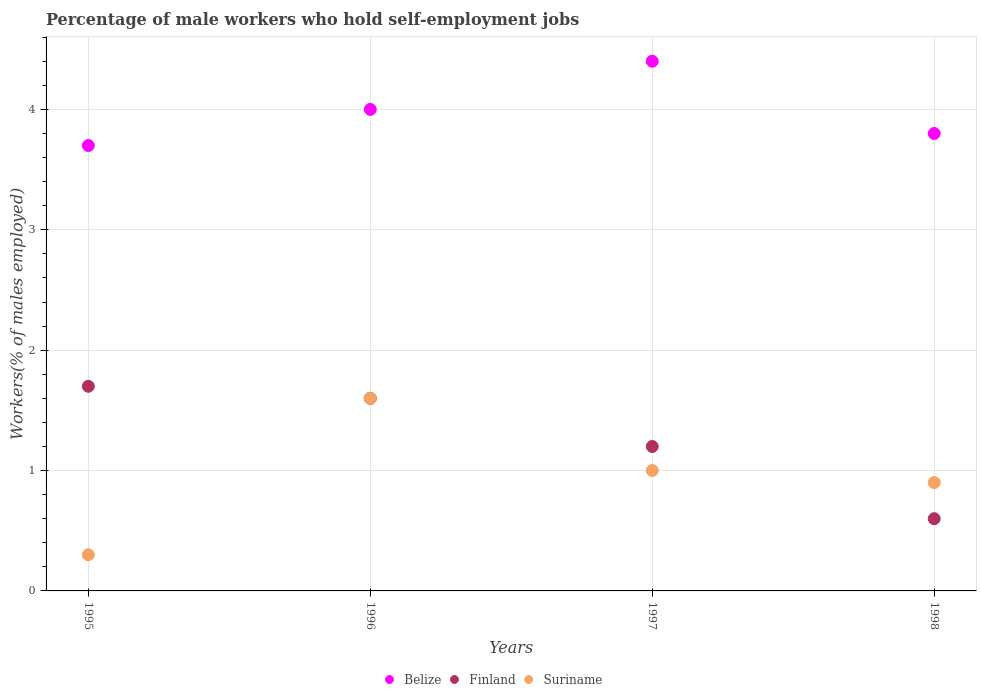How many different coloured dotlines are there?
Keep it short and to the point. 3. Is the number of dotlines equal to the number of legend labels?
Keep it short and to the point. Yes. Across all years, what is the maximum percentage of self-employed male workers in Belize?
Offer a terse response. 4.4. Across all years, what is the minimum percentage of self-employed male workers in Suriname?
Keep it short and to the point. 0.3. In which year was the percentage of self-employed male workers in Finland maximum?
Provide a short and direct response. 1995. In which year was the percentage of self-employed male workers in Finland minimum?
Offer a very short reply. 1998. What is the total percentage of self-employed male workers in Suriname in the graph?
Your response must be concise. 3.8. What is the difference between the percentage of self-employed male workers in Suriname in 1997 and that in 1998?
Your answer should be very brief. 0.1. What is the difference between the percentage of self-employed male workers in Finland in 1998 and the percentage of self-employed male workers in Belize in 1997?
Your response must be concise. -3.8. What is the average percentage of self-employed male workers in Finland per year?
Ensure brevity in your answer.  1.28. In the year 1996, what is the difference between the percentage of self-employed male workers in Finland and percentage of self-employed male workers in Belize?
Offer a very short reply. -2.4. What is the ratio of the percentage of self-employed male workers in Belize in 1996 to that in 1998?
Make the answer very short. 1.05. Is the percentage of self-employed male workers in Finland in 1995 less than that in 1996?
Your response must be concise. No. Is the difference between the percentage of self-employed male workers in Finland in 1996 and 1998 greater than the difference between the percentage of self-employed male workers in Belize in 1996 and 1998?
Keep it short and to the point. Yes. What is the difference between the highest and the second highest percentage of self-employed male workers in Finland?
Offer a very short reply. 0.1. What is the difference between the highest and the lowest percentage of self-employed male workers in Finland?
Keep it short and to the point. 1.1. Is the sum of the percentage of self-employed male workers in Finland in 1995 and 1997 greater than the maximum percentage of self-employed male workers in Suriname across all years?
Provide a succinct answer. Yes. Is it the case that in every year, the sum of the percentage of self-employed male workers in Suriname and percentage of self-employed male workers in Finland  is greater than the percentage of self-employed male workers in Belize?
Make the answer very short. No. Is the percentage of self-employed male workers in Belize strictly greater than the percentage of self-employed male workers in Finland over the years?
Your response must be concise. Yes. How many dotlines are there?
Provide a succinct answer. 3. What is the difference between two consecutive major ticks on the Y-axis?
Your response must be concise. 1. Are the values on the major ticks of Y-axis written in scientific E-notation?
Give a very brief answer. No. Where does the legend appear in the graph?
Give a very brief answer. Bottom center. How many legend labels are there?
Make the answer very short. 3. What is the title of the graph?
Your answer should be compact. Percentage of male workers who hold self-employment jobs. What is the label or title of the Y-axis?
Your answer should be very brief. Workers(% of males employed). What is the Workers(% of males employed) of Belize in 1995?
Make the answer very short. 3.7. What is the Workers(% of males employed) in Finland in 1995?
Your answer should be compact. 1.7. What is the Workers(% of males employed) of Suriname in 1995?
Your response must be concise. 0.3. What is the Workers(% of males employed) in Belize in 1996?
Provide a short and direct response. 4. What is the Workers(% of males employed) of Finland in 1996?
Ensure brevity in your answer.  1.6. What is the Workers(% of males employed) in Suriname in 1996?
Give a very brief answer. 1.6. What is the Workers(% of males employed) in Belize in 1997?
Offer a terse response. 4.4. What is the Workers(% of males employed) of Finland in 1997?
Give a very brief answer. 1.2. What is the Workers(% of males employed) in Belize in 1998?
Give a very brief answer. 3.8. What is the Workers(% of males employed) in Finland in 1998?
Make the answer very short. 0.6. What is the Workers(% of males employed) in Suriname in 1998?
Your answer should be very brief. 0.9. Across all years, what is the maximum Workers(% of males employed) in Belize?
Make the answer very short. 4.4. Across all years, what is the maximum Workers(% of males employed) in Finland?
Provide a short and direct response. 1.7. Across all years, what is the maximum Workers(% of males employed) of Suriname?
Give a very brief answer. 1.6. Across all years, what is the minimum Workers(% of males employed) of Belize?
Provide a succinct answer. 3.7. Across all years, what is the minimum Workers(% of males employed) in Finland?
Offer a terse response. 0.6. Across all years, what is the minimum Workers(% of males employed) of Suriname?
Provide a succinct answer. 0.3. What is the total Workers(% of males employed) in Finland in the graph?
Provide a short and direct response. 5.1. What is the total Workers(% of males employed) of Suriname in the graph?
Offer a very short reply. 3.8. What is the difference between the Workers(% of males employed) of Suriname in 1995 and that in 1996?
Give a very brief answer. -1.3. What is the difference between the Workers(% of males employed) of Belize in 1995 and that in 1997?
Provide a short and direct response. -0.7. What is the difference between the Workers(% of males employed) in Suriname in 1995 and that in 1997?
Provide a succinct answer. -0.7. What is the difference between the Workers(% of males employed) of Belize in 1996 and that in 1997?
Ensure brevity in your answer.  -0.4. What is the difference between the Workers(% of males employed) of Suriname in 1996 and that in 1997?
Keep it short and to the point. 0.6. What is the difference between the Workers(% of males employed) of Belize in 1997 and that in 1998?
Offer a very short reply. 0.6. What is the difference between the Workers(% of males employed) of Finland in 1997 and that in 1998?
Give a very brief answer. 0.6. What is the difference between the Workers(% of males employed) of Belize in 1995 and the Workers(% of males employed) of Finland in 1998?
Provide a short and direct response. 3.1. What is the difference between the Workers(% of males employed) of Belize in 1996 and the Workers(% of males employed) of Finland in 1998?
Offer a very short reply. 3.4. What is the difference between the Workers(% of males employed) of Belize in 1997 and the Workers(% of males employed) of Finland in 1998?
Keep it short and to the point. 3.8. What is the difference between the Workers(% of males employed) in Belize in 1997 and the Workers(% of males employed) in Suriname in 1998?
Keep it short and to the point. 3.5. What is the difference between the Workers(% of males employed) of Finland in 1997 and the Workers(% of males employed) of Suriname in 1998?
Your answer should be very brief. 0.3. What is the average Workers(% of males employed) of Belize per year?
Offer a terse response. 3.98. What is the average Workers(% of males employed) of Finland per year?
Offer a very short reply. 1.27. What is the average Workers(% of males employed) of Suriname per year?
Provide a succinct answer. 0.95. In the year 1995, what is the difference between the Workers(% of males employed) of Belize and Workers(% of males employed) of Finland?
Provide a succinct answer. 2. In the year 1996, what is the difference between the Workers(% of males employed) of Belize and Workers(% of males employed) of Finland?
Your response must be concise. 2.4. In the year 1996, what is the difference between the Workers(% of males employed) in Finland and Workers(% of males employed) in Suriname?
Your response must be concise. 0. In the year 1997, what is the difference between the Workers(% of males employed) in Belize and Workers(% of males employed) in Finland?
Your answer should be compact. 3.2. In the year 1998, what is the difference between the Workers(% of males employed) in Belize and Workers(% of males employed) in Finland?
Keep it short and to the point. 3.2. In the year 1998, what is the difference between the Workers(% of males employed) in Belize and Workers(% of males employed) in Suriname?
Your response must be concise. 2.9. What is the ratio of the Workers(% of males employed) of Belize in 1995 to that in 1996?
Ensure brevity in your answer.  0.93. What is the ratio of the Workers(% of males employed) of Finland in 1995 to that in 1996?
Your answer should be compact. 1.06. What is the ratio of the Workers(% of males employed) in Suriname in 1995 to that in 1996?
Your answer should be compact. 0.19. What is the ratio of the Workers(% of males employed) of Belize in 1995 to that in 1997?
Provide a short and direct response. 0.84. What is the ratio of the Workers(% of males employed) in Finland in 1995 to that in 1997?
Your response must be concise. 1.42. What is the ratio of the Workers(% of males employed) of Belize in 1995 to that in 1998?
Keep it short and to the point. 0.97. What is the ratio of the Workers(% of males employed) of Finland in 1995 to that in 1998?
Give a very brief answer. 2.83. What is the ratio of the Workers(% of males employed) in Suriname in 1995 to that in 1998?
Provide a short and direct response. 0.33. What is the ratio of the Workers(% of males employed) of Finland in 1996 to that in 1997?
Your answer should be compact. 1.33. What is the ratio of the Workers(% of males employed) of Suriname in 1996 to that in 1997?
Make the answer very short. 1.6. What is the ratio of the Workers(% of males employed) in Belize in 1996 to that in 1998?
Your response must be concise. 1.05. What is the ratio of the Workers(% of males employed) in Finland in 1996 to that in 1998?
Make the answer very short. 2.67. What is the ratio of the Workers(% of males employed) of Suriname in 1996 to that in 1998?
Offer a terse response. 1.78. What is the ratio of the Workers(% of males employed) in Belize in 1997 to that in 1998?
Provide a succinct answer. 1.16. What is the ratio of the Workers(% of males employed) in Finland in 1997 to that in 1998?
Your response must be concise. 2. What is the ratio of the Workers(% of males employed) in Suriname in 1997 to that in 1998?
Provide a succinct answer. 1.11. What is the difference between the highest and the second highest Workers(% of males employed) of Belize?
Provide a succinct answer. 0.4. What is the difference between the highest and the second highest Workers(% of males employed) in Finland?
Make the answer very short. 0.1. What is the difference between the highest and the lowest Workers(% of males employed) in Finland?
Offer a very short reply. 1.1. What is the difference between the highest and the lowest Workers(% of males employed) of Suriname?
Your answer should be very brief. 1.3. 